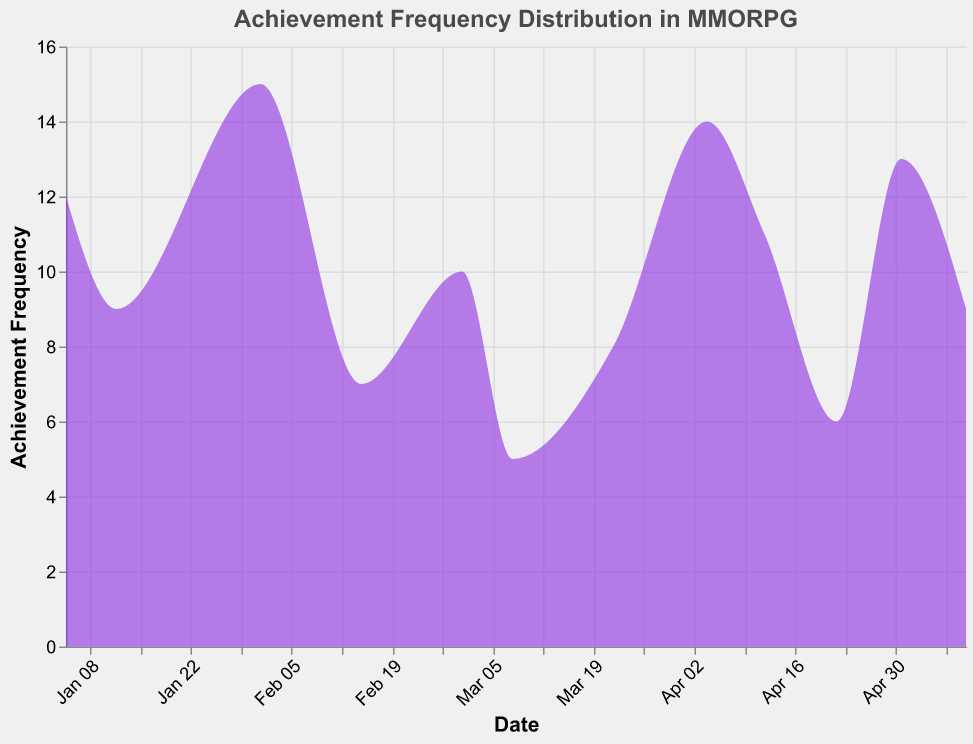What is the title of the plot? The title of the plot is located at the top and indicates the main topic of the visualization. It specifies "Achievement Frequency Distribution in MMORPG".
Answer: Achievement Frequency Distribution in MMORPG What does the color of the area represent? The area in the plot is represented by a purple color with a fill opacity of 0.6 to indicate the distribution density of the achievement frequencies over time.
Answer: Achievement frequency distribution Which achievement has the highest frequency and what is that frequency? The tooltip when hovering over the peaks will display the achievement and its frequency. "Aurene's Ascension" has the highest frequency as shown by the peak on February 1st, with a frequency of 15.
Answer: "Aurene's Ascension", 15 How many achievements have a frequency of more than 10? By examining the y-axis and correlating peaks above the value of 10, there are four achievements: "Defeated Zhaitan", "Aurene's Ascension", "Raided Successfully", and "Guild Wars Tribute".
Answer: 4 Which date range shows the most variation in achievement frequency? The period with the most peaks and varied heights indicate the most variation. This can be seen from late March to early May where frequencies rise and fall significantly.
Answer: Late March to early May Which achievement unlocked in April has the lowest frequency? By checking the points around April, "Eternal Champion" on April 22nd, with a frequency of 6, is the lowest-frequency achievement for the month.
Answer: "Eternal Champion" What is the average frequency of the achievements unlocked in March? Calculate the mean of the frequencies for March achievements. Achievements are "Revenant's Journey" (10), "Unlocked All Mounts" (5), and "Dragonfall Conqueror" (8). (10+5+8)/3 = 7.67
Answer: 7.67 Compare the frequency of achievements unlocked in February. Which one is higher? February achievements are "Aurene's Ascension" with a frequency of 15 and "Crafted Legendary Weapon" with 7. Comparing 15 and 7, 15 is higher.
Answer: "Aurene's Ascension" What is the overall trend of achievement frequency from January to May? By examining the curve from left (January) to right (May), there is an irregular pattern of peaks and valleys but there seems to be no consistent increasing or decreasing trend over the months.
Answer: No consistent trend How does the frequency of "Raided Successfully" compare to "Heart of Thorns Completion"? "Raided Successfully" on April 4th has a frequency of 14, whereas "Heart of Thorns Completion" on May 10th has a frequency of 9. Comparing these, 14 is greater than 9.
Answer: Greater 